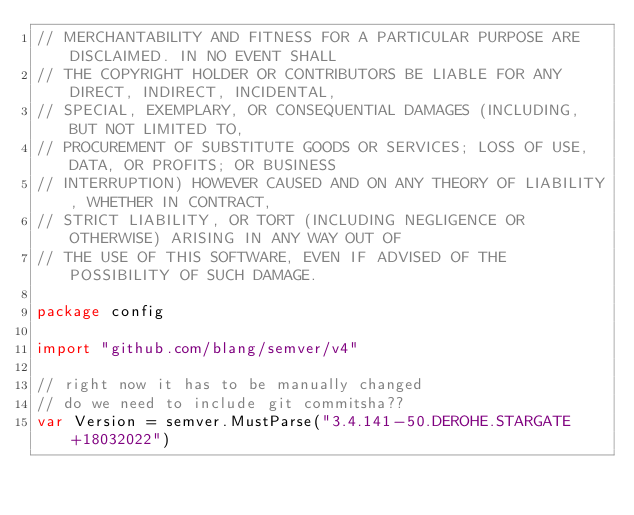Convert code to text. <code><loc_0><loc_0><loc_500><loc_500><_Go_>// MERCHANTABILITY AND FITNESS FOR A PARTICULAR PURPOSE ARE DISCLAIMED. IN NO EVENT SHALL
// THE COPYRIGHT HOLDER OR CONTRIBUTORS BE LIABLE FOR ANY DIRECT, INDIRECT, INCIDENTAL,
// SPECIAL, EXEMPLARY, OR CONSEQUENTIAL DAMAGES (INCLUDING, BUT NOT LIMITED TO,
// PROCUREMENT OF SUBSTITUTE GOODS OR SERVICES; LOSS OF USE, DATA, OR PROFITS; OR BUSINESS
// INTERRUPTION) HOWEVER CAUSED AND ON ANY THEORY OF LIABILITY, WHETHER IN CONTRACT,
// STRICT LIABILITY, OR TORT (INCLUDING NEGLIGENCE OR OTHERWISE) ARISING IN ANY WAY OUT OF
// THE USE OF THIS SOFTWARE, EVEN IF ADVISED OF THE POSSIBILITY OF SUCH DAMAGE.

package config

import "github.com/blang/semver/v4"

// right now it has to be manually changed
// do we need to include git commitsha??
var Version = semver.MustParse("3.4.141-50.DEROHE.STARGATE+18032022")
</code> 